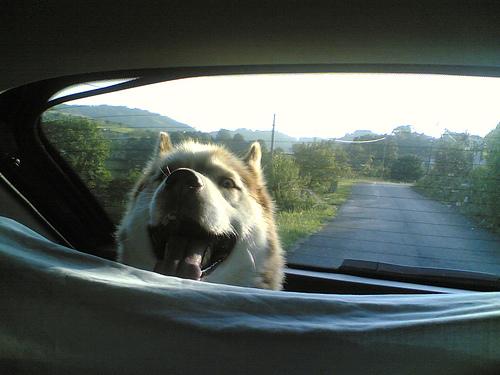What kind of animal is this?
Write a very short answer. Dog. Where is the animal located?
Be succinct. Car. Is the dog's tongue hanging out?
Write a very short answer. Yes. 